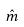<formula> <loc_0><loc_0><loc_500><loc_500>\hat { m }</formula> 